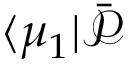<formula> <loc_0><loc_0><loc_500><loc_500>\langle \mu _ { 1 } | \bar { \mathcal { P } }</formula> 